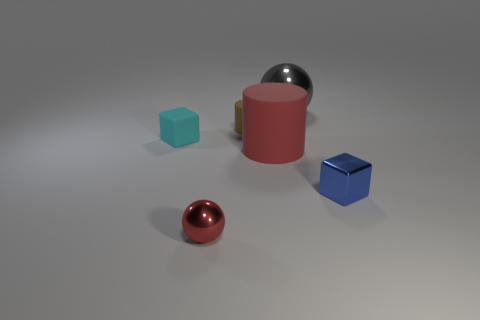Add 4 big red objects. How many objects exist? 10 Subtract all cylinders. How many objects are left? 4 Subtract all cyan shiny things. Subtract all tiny metal cubes. How many objects are left? 5 Add 6 tiny blocks. How many tiny blocks are left? 8 Add 6 tiny blue cubes. How many tiny blue cubes exist? 7 Subtract 1 cyan blocks. How many objects are left? 5 